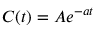Convert formula to latex. <formula><loc_0><loc_0><loc_500><loc_500>C ( t ) = A e ^ { - a t }</formula> 